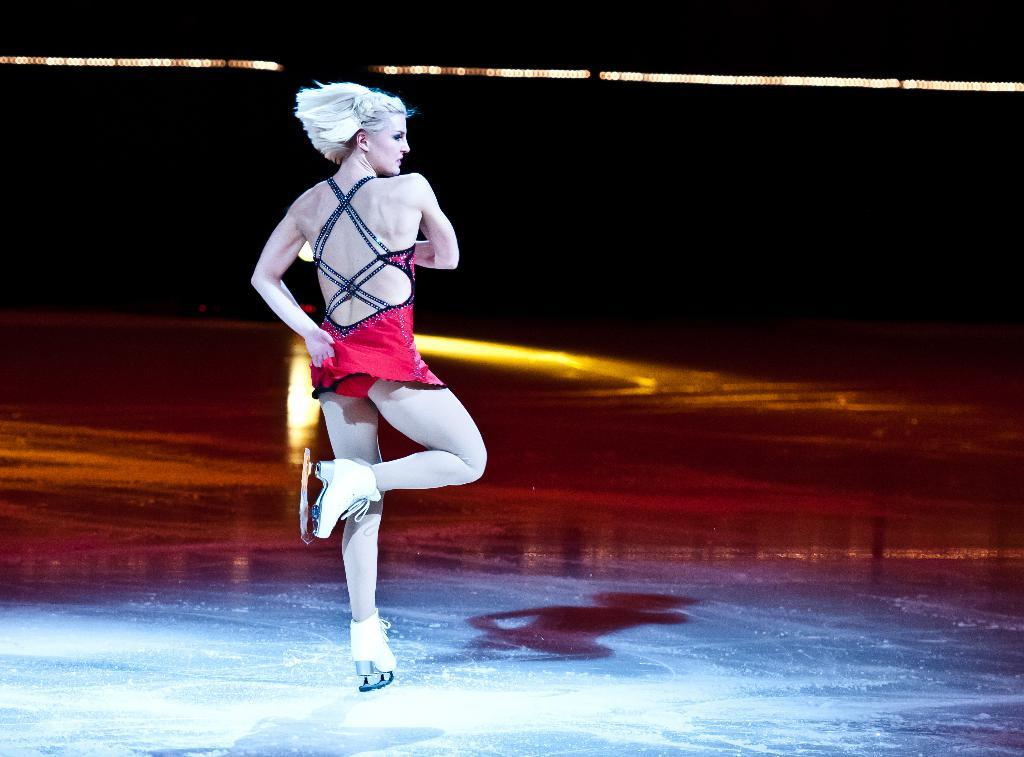Who is present in the image? There is a woman in the image. What can be seen in the image besides the woman? There are lights visible in the image. How would you describe the background of the image? The background of the image is dark. How many girls are present in the image? There is no mention of girls in the image; only a woman is present. What type of coil can be seen in the image? There is no coil present in the image. 